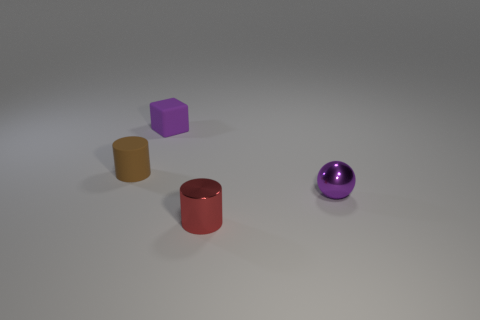Add 3 purple matte cubes. How many objects exist? 7 Subtract 2 cylinders. How many cylinders are left? 0 Subtract all blocks. How many objects are left? 3 Subtract all yellow cylinders. How many red spheres are left? 0 Subtract all gray shiny things. Subtract all rubber objects. How many objects are left? 2 Add 4 brown objects. How many brown objects are left? 5 Add 4 cyan balls. How many cyan balls exist? 4 Subtract 1 red cylinders. How many objects are left? 3 Subtract all red blocks. Subtract all red balls. How many blocks are left? 1 